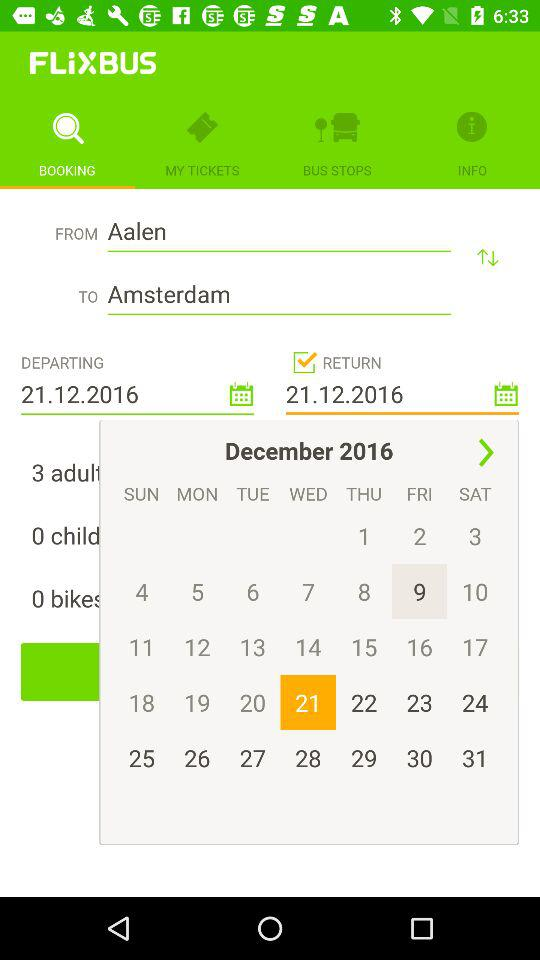How many adults are there in the booking?
Answer the question using a single word or phrase. 3 